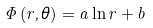<formula> <loc_0><loc_0><loc_500><loc_500>\Phi \left ( r , \theta \right ) = a \ln r + b</formula> 